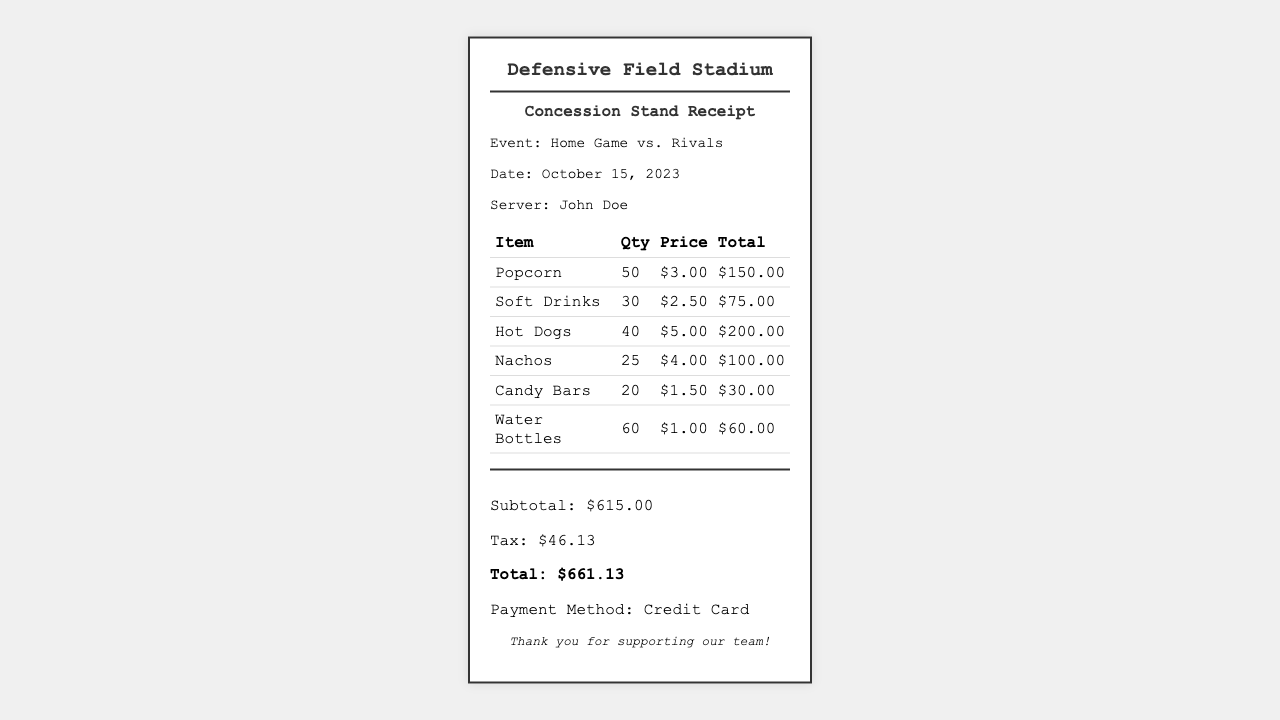What is the date of the event? The date of the event is mentioned in the information section of the receipt.
Answer: October 15, 2023 Who was the server at the concession stand? The server's name is provided in the information section of the receipt.
Answer: John Doe How many soft drinks were sold? The quantity of soft drinks sold is listed in the itemized table of the receipt.
Answer: 30 What is the total amount of tax? The total amount of tax is shown in the totals section of the receipt.
Answer: $46.13 What is the price of one hot dog? The price per hot dog is stated in the itemized table of the receipt.
Answer: $5.00 What is the total sales revenue from popcorn? The total sales revenue from popcorn can be calculated as the quantity sold multiplied by the price.
Answer: $150.00 What is the total for all items before tax? The subtotal before tax is provided in the totals section of the receipt.
Answer: $615.00 How many water bottles were sold? The quantity of water bottles sold is indicated in the itemized table of the receipt.
Answer: 60 What payment method was used? The payment method is specified at the bottom of the receipt.
Answer: Credit Card 